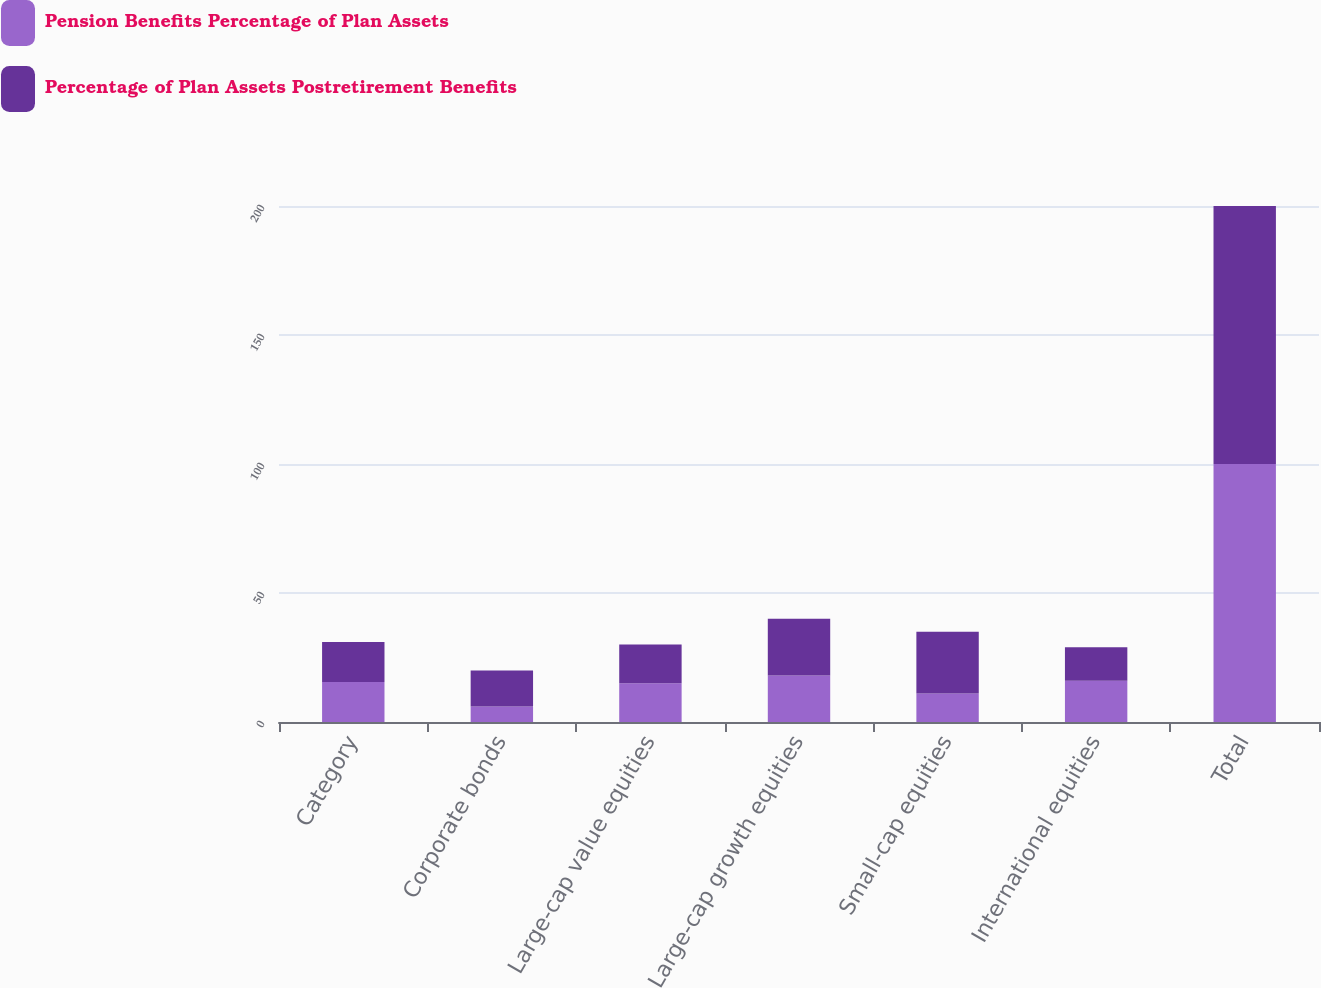Convert chart. <chart><loc_0><loc_0><loc_500><loc_500><stacked_bar_chart><ecel><fcel>Category<fcel>Corporate bonds<fcel>Large-cap value equities<fcel>Large-cap growth equities<fcel>Small-cap equities<fcel>International equities<fcel>Total<nl><fcel>Pension Benefits Percentage of Plan Assets<fcel>15.5<fcel>6<fcel>15<fcel>18<fcel>11<fcel>16<fcel>100<nl><fcel>Percentage of Plan Assets Postretirement Benefits<fcel>15.5<fcel>14<fcel>15<fcel>22<fcel>24<fcel>13<fcel>100<nl></chart> 